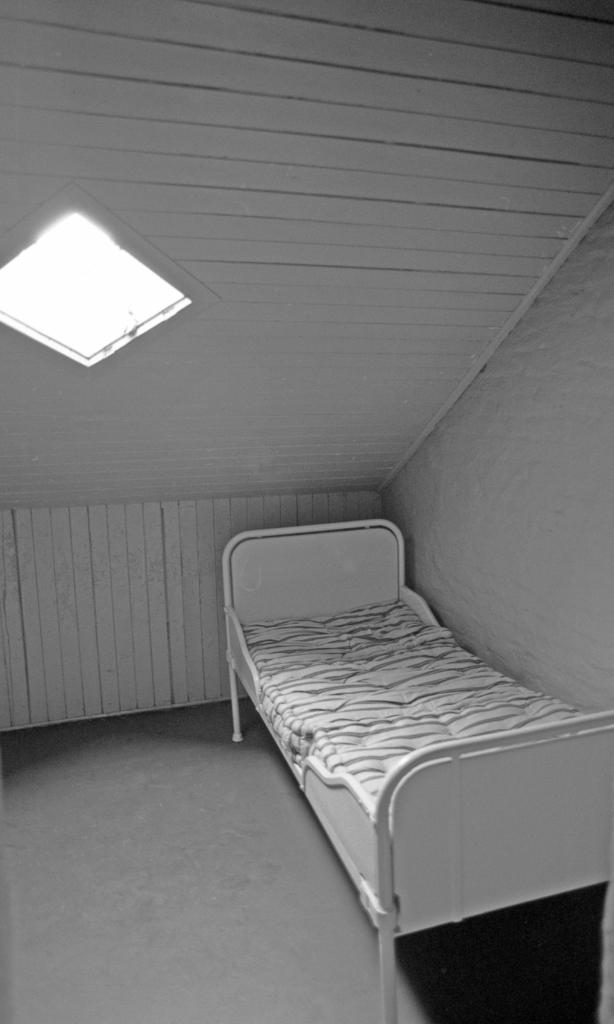What is the color scheme of the image? The image is black and white. What piece of furniture can be seen in the image? There is a bed in the image. What is located beside the bed? There is a wall beside the bed. What is located above the bed? There is a roof above the bed. What type of weather can be seen through the pocket in the image? There is no pocket present in the image, and therefore no weather can be seen through it. 